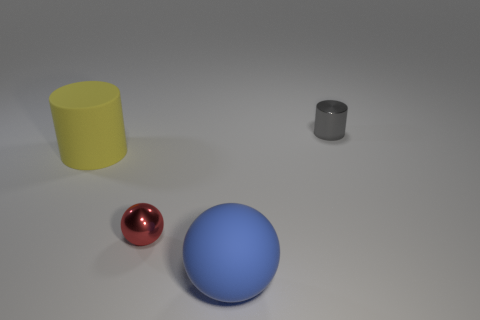What material is the thing that is in front of the metallic object that is on the left side of the small gray cylinder?
Your answer should be compact. Rubber. The other thing that is made of the same material as the large blue thing is what color?
Offer a very short reply. Yellow. There is a cylinder that is left of the large blue rubber thing; does it have the same size as the matte thing to the right of the metal ball?
Provide a succinct answer. Yes. What number of blocks are either yellow things or small gray things?
Provide a short and direct response. 0. Is the cylinder left of the blue object made of the same material as the large blue object?
Offer a very short reply. Yes. How many other things are the same size as the matte ball?
Provide a short and direct response. 1. What number of big things are either blue matte cylinders or red shiny objects?
Make the answer very short. 0. Are there more big objects that are to the left of the tiny red object than tiny gray shiny objects behind the large yellow rubber cylinder?
Your answer should be compact. No. Are there any other things that have the same color as the tiny sphere?
Provide a short and direct response. No. Are there more large cylinders on the left side of the small gray object than big red balls?
Keep it short and to the point. Yes. 